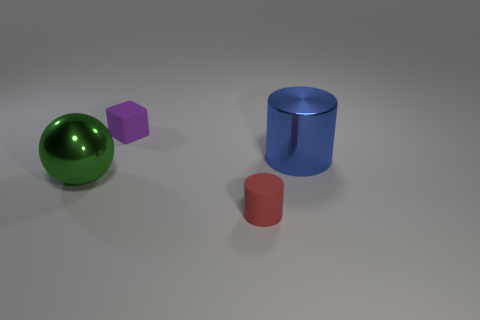Add 3 green balls. How many objects exist? 7 Subtract all cubes. How many objects are left? 3 Add 2 tiny gray spheres. How many tiny gray spheres exist? 2 Subtract 0 brown spheres. How many objects are left? 4 Subtract all purple rubber cubes. Subtract all small blue rubber balls. How many objects are left? 3 Add 4 tiny purple things. How many tiny purple things are left? 5 